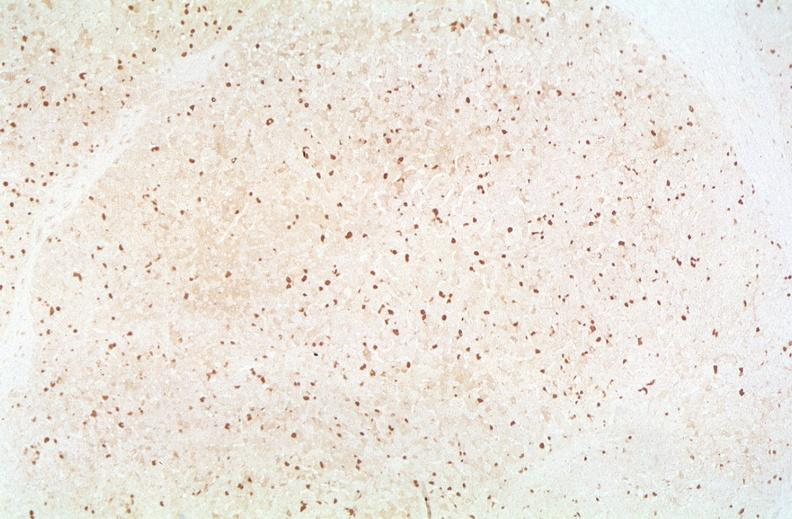what is present?
Answer the question using a single word or phrase. Liver 